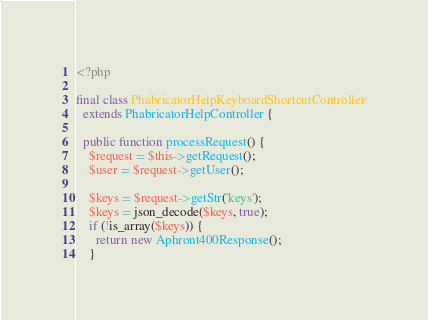Convert code to text. <code><loc_0><loc_0><loc_500><loc_500><_PHP_><?php

final class PhabricatorHelpKeyboardShortcutController
  extends PhabricatorHelpController {

  public function processRequest() {
    $request = $this->getRequest();
    $user = $request->getUser();

    $keys = $request->getStr('keys');
    $keys = json_decode($keys, true);
    if (!is_array($keys)) {
      return new Aphront400Response();
    }
</code> 